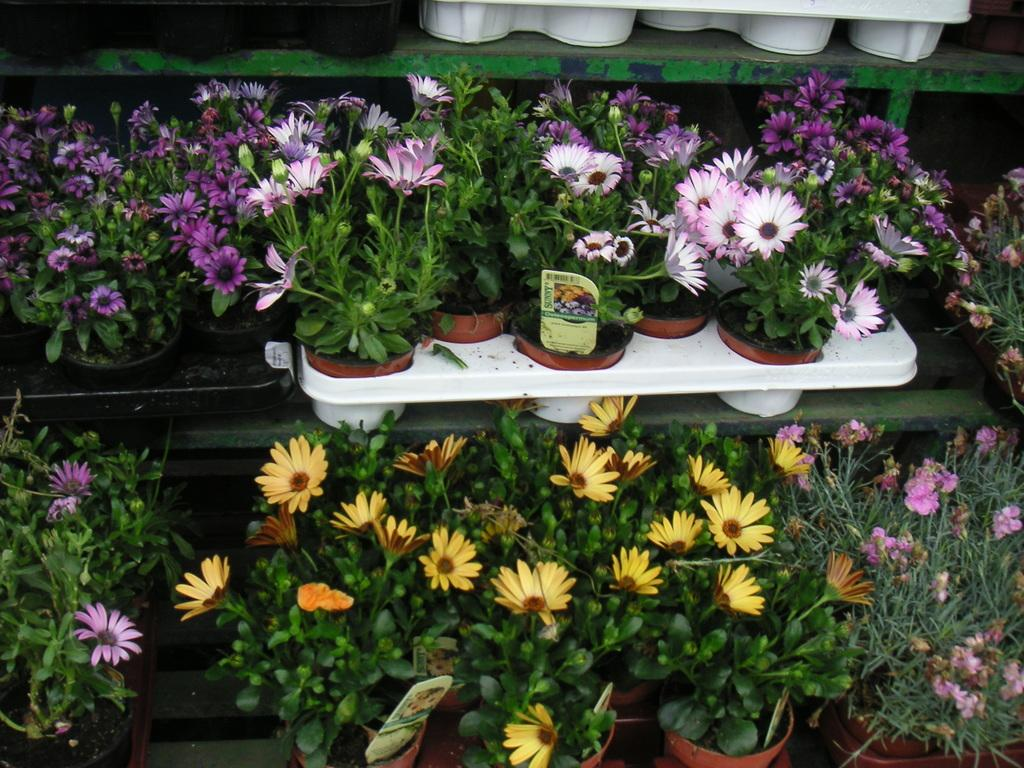What type of furniture is present in the image? There are shelves in the image. What kind of plants can be seen on the shelves? There are house plants with flowers in the image. What else is present on the shelves besides the plants? There are cards in the image. What type of weather can be seen in the image? There is no weather depicted in the image, as it is an indoor scene with shelves, plants, and cards. 